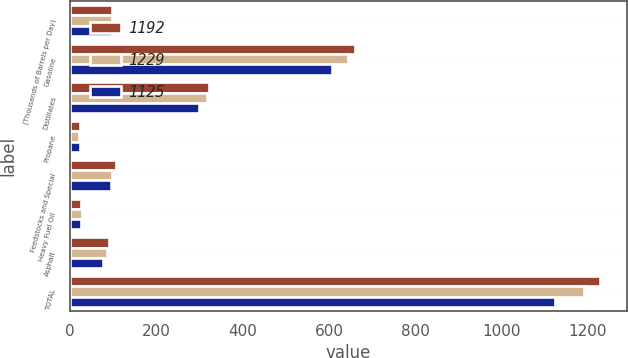Convert chart. <chart><loc_0><loc_0><loc_500><loc_500><stacked_bar_chart><ecel><fcel>(Thousands of Barrels per Day)<fcel>Gasoline<fcel>Distillates<fcel>Propane<fcel>Feedstocks and Special<fcel>Heavy Fuel Oil<fcel>Asphalt<fcel>TOTAL<nl><fcel>1192<fcel>96<fcel>661<fcel>323<fcel>23<fcel>107<fcel>26<fcel>89<fcel>1229<nl><fcel>1229<fcel>96<fcel>644<fcel>318<fcel>21<fcel>96<fcel>28<fcel>85<fcel>1192<nl><fcel>1125<fcel>96<fcel>608<fcel>299<fcel>22<fcel>94<fcel>25<fcel>77<fcel>1125<nl></chart> 